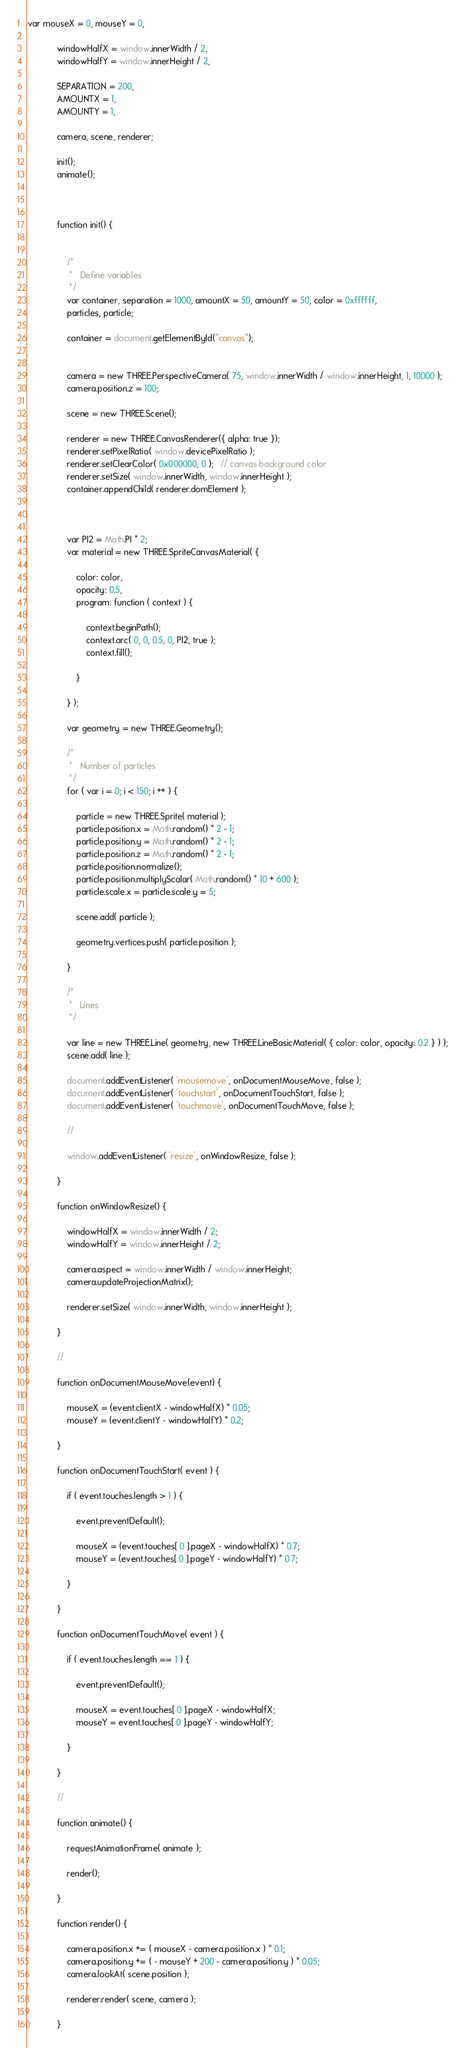Convert code to text. <code><loc_0><loc_0><loc_500><loc_500><_JavaScript_>var mouseX = 0, mouseY = 0,

            windowHalfX = window.innerWidth / 2,
            windowHalfY = window.innerHeight / 2,

            SEPARATION = 200,
            AMOUNTX = 1,
            AMOUNTY = 1,

            camera, scene, renderer;

            init();
            animate();



            function init() {


                /*
                 *   Define variables
                 */
                var container, separation = 1000, amountX = 50, amountY = 50, color = 0xffffff,
                particles, particle;

                container = document.getElementById("canvas");


                camera = new THREE.PerspectiveCamera( 75, window.innerWidth / window.innerHeight, 1, 10000 );
                camera.position.z = 100;

                scene = new THREE.Scene();

                renderer = new THREE.CanvasRenderer({ alpha: true });
                renderer.setPixelRatio( window.devicePixelRatio );
                renderer.setClearColor( 0x000000, 0 );   // canvas background color
                renderer.setSize( window.innerWidth, window.innerHeight );
                container.appendChild( renderer.domElement );

               

                var PI2 = Math.PI * 2;
                var material = new THREE.SpriteCanvasMaterial( {

                    color: color,
                    opacity: 0.5,
                    program: function ( context ) {

                        context.beginPath();
                        context.arc( 0, 0, 0.5, 0, PI2, true );
                        context.fill();

                    }

                } );

                var geometry = new THREE.Geometry();

                /*
                 *   Number of particles
                 */
                for ( var i = 0; i < 150; i ++ ) {

                    particle = new THREE.Sprite( material );
                    particle.position.x = Math.random() * 2 - 1;
                    particle.position.y = Math.random() * 2 - 1;
                    particle.position.z = Math.random() * 2 - 1;
                    particle.position.normalize();
                    particle.position.multiplyScalar( Math.random() * 10 + 600 );
                    particle.scale.x = particle.scale.y = 5;

                    scene.add( particle );

                    geometry.vertices.push( particle.position );

                }

                /*
                 *   Lines
                 */

                var line = new THREE.Line( geometry, new THREE.LineBasicMaterial( { color: color, opacity: 0.2 } ) );
                scene.add( line );

                document.addEventListener( 'mousemove', onDocumentMouseMove, false );
                document.addEventListener( 'touchstart', onDocumentTouchStart, false );
                document.addEventListener( 'touchmove', onDocumentTouchMove, false );

                //

                window.addEventListener( 'resize', onWindowResize, false );

            }

            function onWindowResize() {

                windowHalfX = window.innerWidth / 2;
                windowHalfY = window.innerHeight / 2;

                camera.aspect = window.innerWidth / window.innerHeight;
                camera.updateProjectionMatrix();

                renderer.setSize( window.innerWidth, window.innerHeight );

            }

            //

            function onDocumentMouseMove(event) {

                mouseX = (event.clientX - windowHalfX) * 0.05;
                mouseY = (event.clientY - windowHalfY) * 0.2;

            }

            function onDocumentTouchStart( event ) {

                if ( event.touches.length > 1 ) {

                    event.preventDefault();

                    mouseX = (event.touches[ 0 ].pageX - windowHalfX) * 0.7;
                    mouseY = (event.touches[ 0 ].pageY - windowHalfY) * 0.7;

                }

            }

            function onDocumentTouchMove( event ) {

                if ( event.touches.length == 1 ) {

                    event.preventDefault();

                    mouseX = event.touches[ 0 ].pageX - windowHalfX;
                    mouseY = event.touches[ 0 ].pageY - windowHalfY;

                }

            }

            //

            function animate() {

                requestAnimationFrame( animate );

                render();

            }

            function render() {

                camera.position.x += ( mouseX - camera.position.x ) * 0.1;
                camera.position.y += ( - mouseY + 200 - camera.position.y ) * 0.05;
                camera.lookAt( scene.position );

                renderer.render( scene, camera );

            }
</code> 